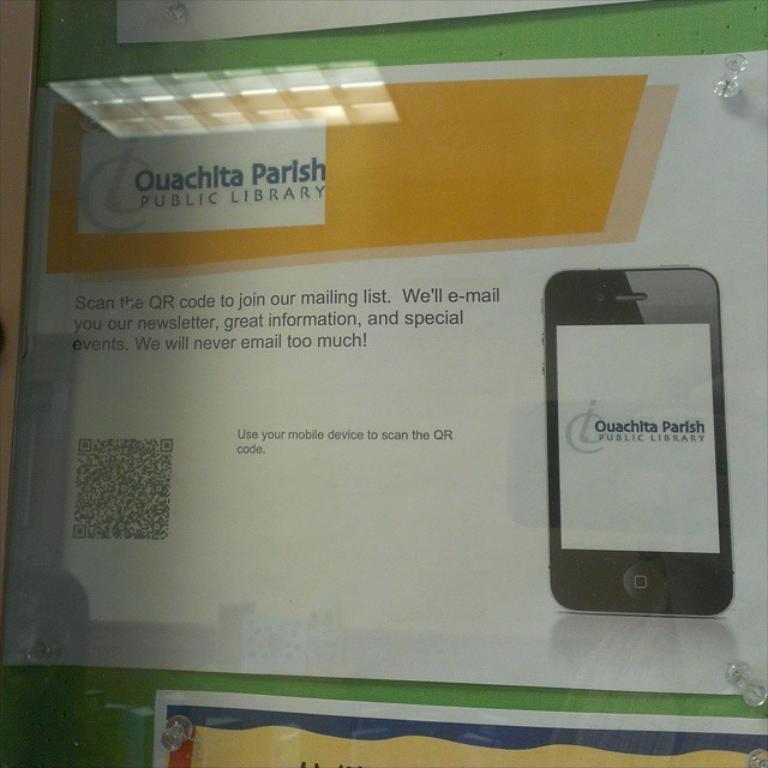Which library is this?
Keep it short and to the point. Ouachita parish. What is on the phone?
Provide a succinct answer. Ouachita parish public library. 